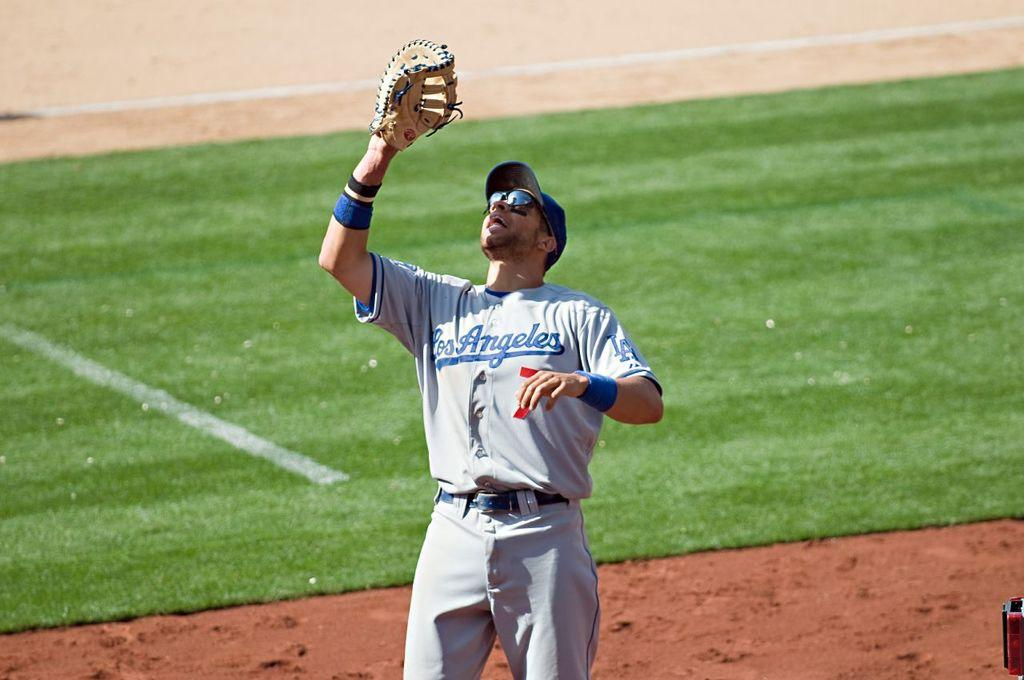Provide a one-sentence caption for the provided image. A baseball player wears a Los Angeles uniform. 